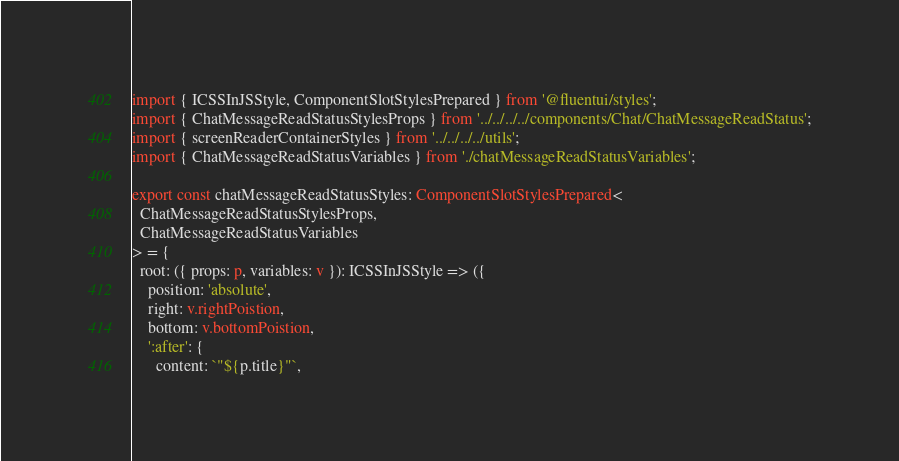Convert code to text. <code><loc_0><loc_0><loc_500><loc_500><_TypeScript_>import { ICSSInJSStyle, ComponentSlotStylesPrepared } from '@fluentui/styles';
import { ChatMessageReadStatusStylesProps } from '../../../../components/Chat/ChatMessageReadStatus';
import { screenReaderContainerStyles } from '../../../../utils';
import { ChatMessageReadStatusVariables } from './chatMessageReadStatusVariables';

export const chatMessageReadStatusStyles: ComponentSlotStylesPrepared<
  ChatMessageReadStatusStylesProps,
  ChatMessageReadStatusVariables
> = {
  root: ({ props: p, variables: v }): ICSSInJSStyle => ({
    position: 'absolute',
    right: v.rightPoistion,
    bottom: v.bottomPoistion,
    ':after': {
      content: `"${p.title}"`,</code> 